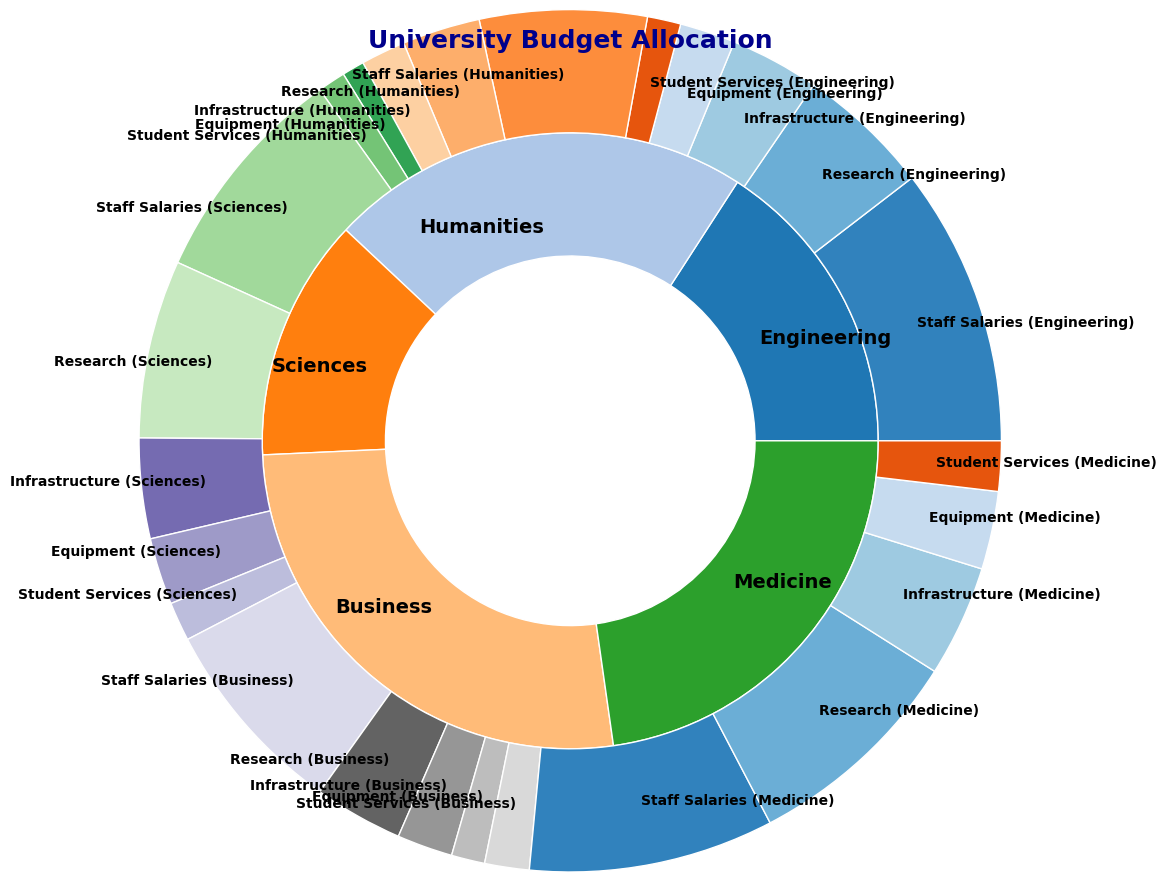Which faculty has the highest overall budget allocation? The nested pie chart shows the total budget allocations by faculty. We sum the expenditures in the outer ring for each faculty and compare. Engineering has the highest values visually.
Answer: Engineering What is the total amount allocated to Staff Salaries across all faculties? To find the total, sum the values for Staff Salaries from each faculty: 2500000 (Engineering) + 1500000 (Humanities) + 2000000 (Sciences) + 1800000 (Business) + 2200000 (Medicine).
Answer: 10000000 Which faculty has the smallest allocation for Equipment? By visually inspecting the outer ring slices labeled as Equipment, Humanities appears to have the smallest size.
Answer: Humanities What's the visual difference in size between the Humanities and Sciences budget segments? Look at the inner ring and compare the size of the slices for Humanities and Sciences, with Sciences appearing larger.
Answer: Sciences is larger Compare the allocation for Research between Engineering and Medicine. Which is higher? Analyze the outer ring slices labeled Research for both faculties. Medicine's slice is larger than Engineering's.
Answer: Medicine How much more is allocated to Student Services in Medicine compared to Engineering? Subtract Medicine's allocation for Student Services (450000) from Engineering's (300000).
Answer: 150000 What percentage of the Humanities budget is allocated to Infrastructure? Divide Humanities' amount for Infrastructure (400000) by Humanities' total budget (sum of inner ring segment) and multiply by 100. Calculation: 400000 / 3050000 * 100.
Answer: 13.11% Which expenditure area in Business has the least allocation? Observe the outer ring slices for Business. The smallest slice is Equipment.
Answer: Equipment If the total budget for Student Services across all faculties needed to be found, how would you calculate it? Sum the amounts allocated to Student Services from each faculty: 300000 (Engineering) + 250000 (Humanities) + 350000 (Sciences) + 400000 (Business) + 450000 (Medicine).
Answer: 1750000 What is the combined budget for Infrastructure and Equipment in Sciences? Sum the values for Infrastructure (900000) and Equipment (600000) directly from the figure.
Answer: 1500000 